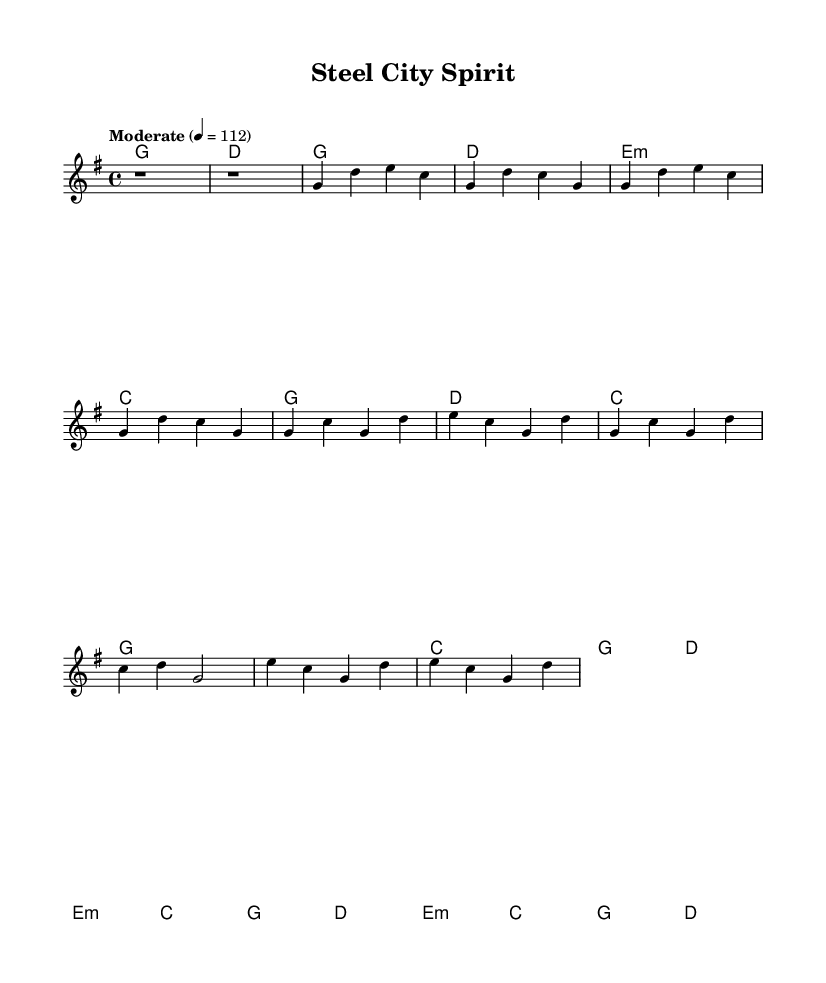What is the key signature of this music? The key signature indicates that there is one sharp, which is consistent with G major.
Answer: G major What is the time signature of the piece? The time signature is indicated at the beginning of the score and shows a four beat measure, written as 4/4.
Answer: 4/4 What is the tempo marking for the piece? The tempo marking specifies a moderate pace, indicated as "Moderate" with a beat of 112.
Answer: Moderate What is the first chord in the score? The first chord is placed at the start of the score and is a G major chord, indicated by the letters in the chord mode.
Answer: G How many measures are in the chorus section of the score? The chorus section can be analyzed by counting the measures that fall between the labeled section, which reveals there are four measures.
Answer: 4 What note does the melody start on? The melody section begins with a rest, followed by the note G, which is in the first active measure.
Answer: G In which section of the music does the bridge appear? The bridge is indicated by a distinct label in the structure of the music and marks the transition highlighting different chords, appearing after the chorus.
Answer: After the chorus 